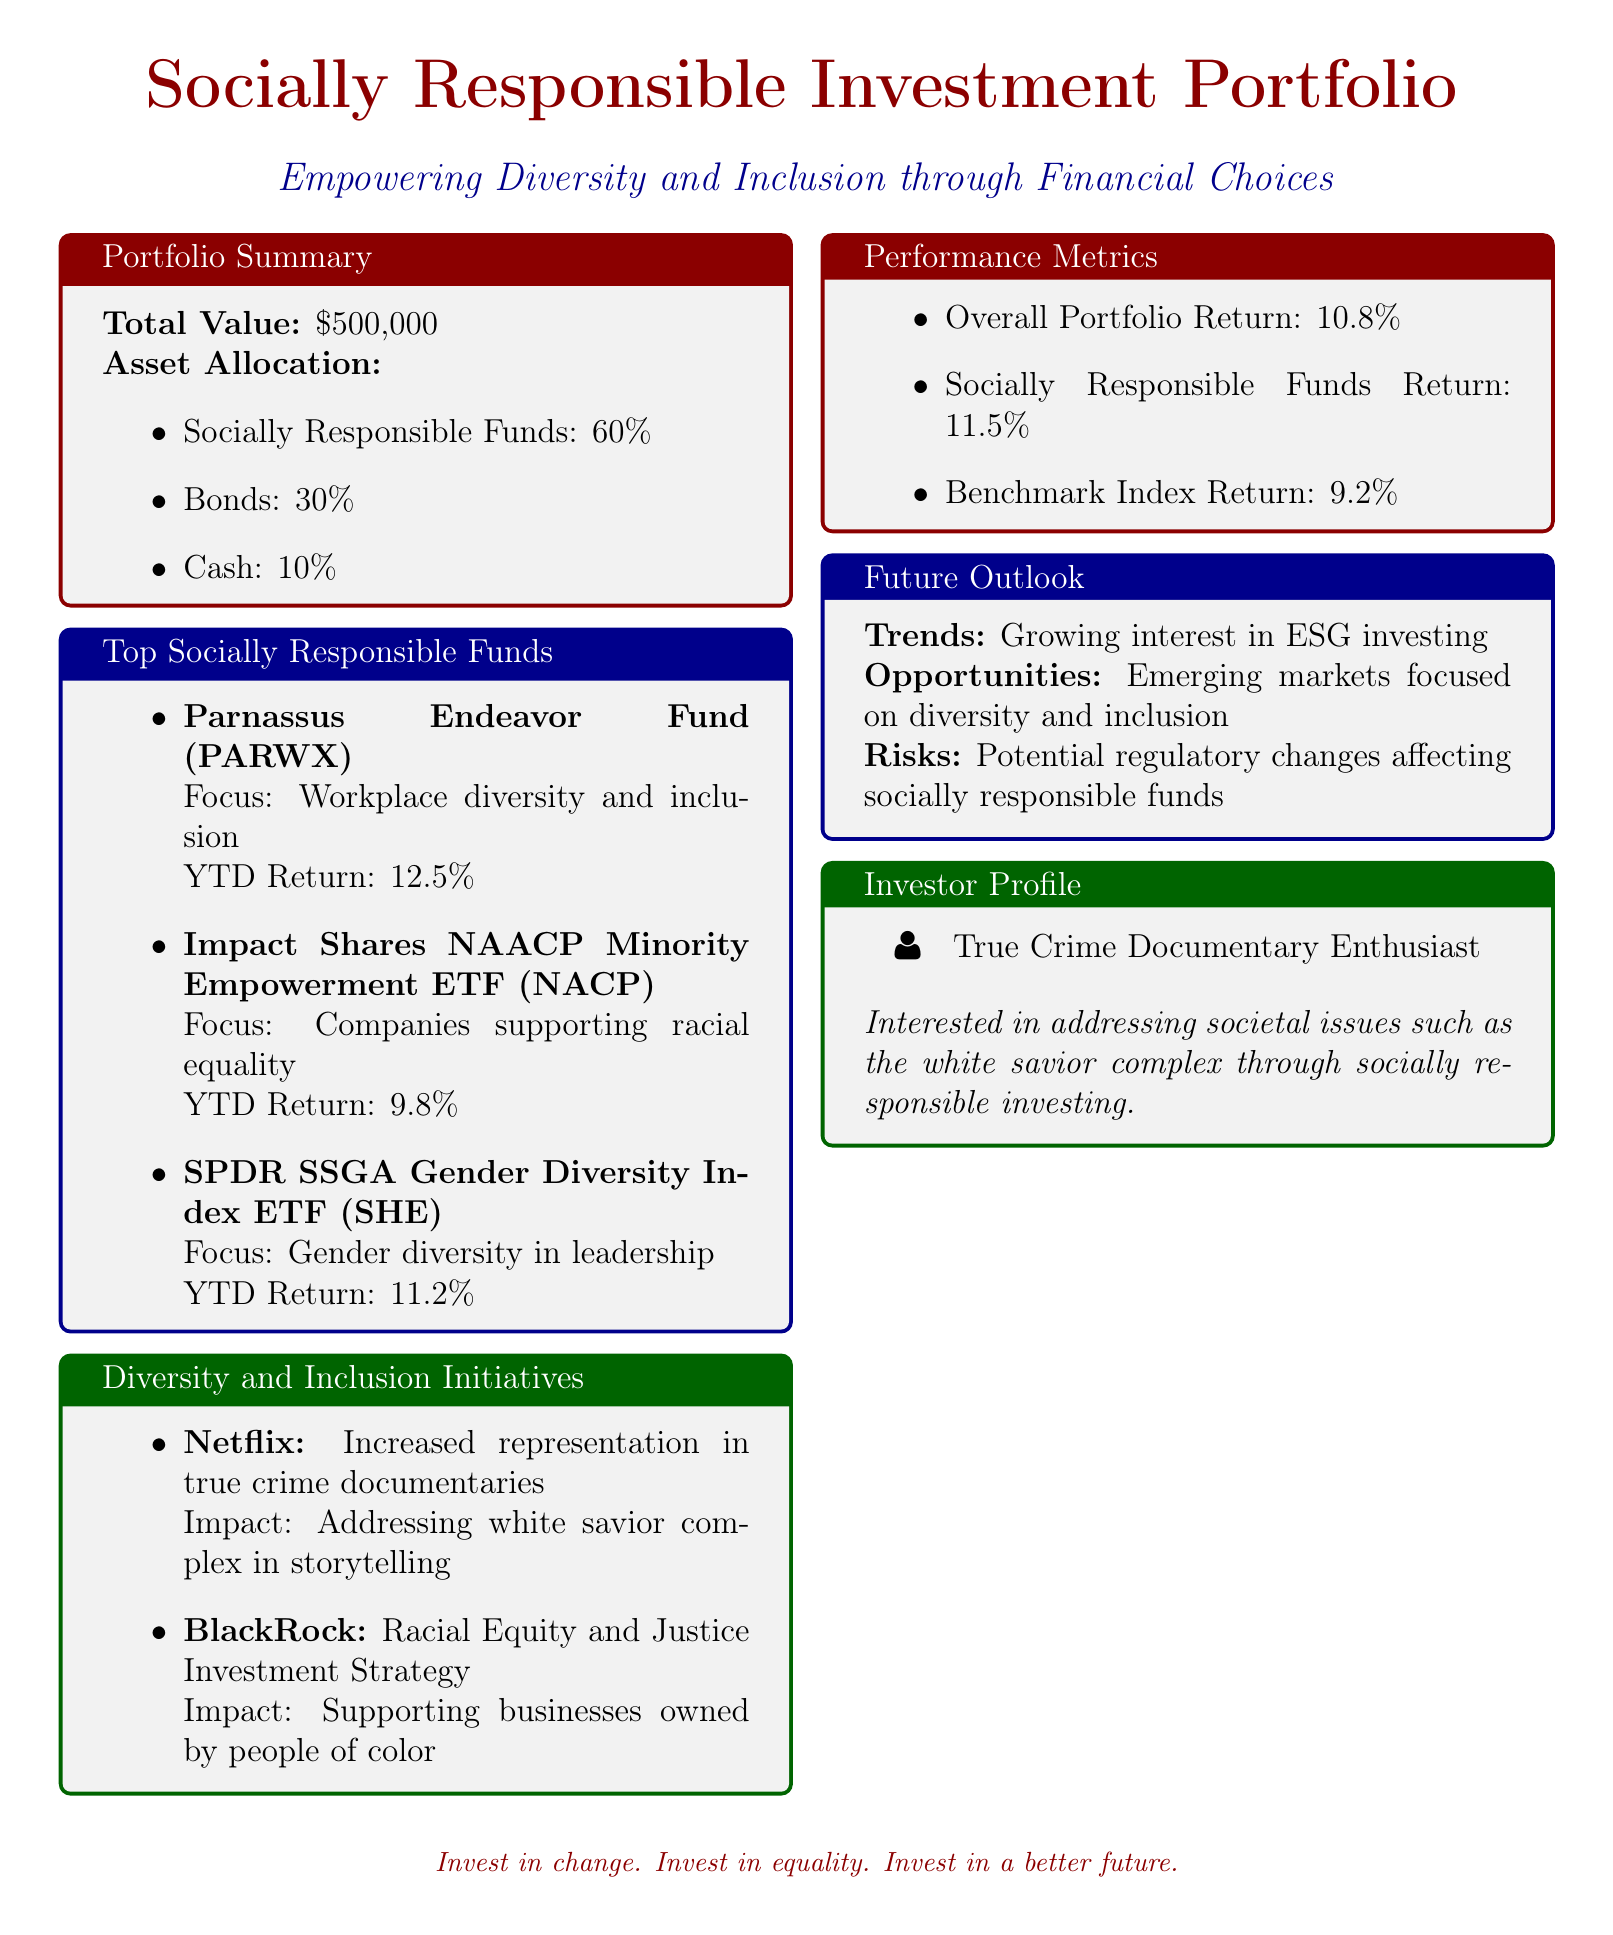What is the total value of the portfolio? The total value is explicitly stated in the portfolio summary section of the document.
Answer: $500,000 What percentage of the asset allocation is in socially responsible funds? The document specifies the percentage allocated to socially responsible funds in the asset allocation section.
Answer: 60% Which fund focuses on workplace diversity and inclusion? The top socially responsible funds section lists several funds, one of which focuses on workplace diversity and inclusion.
Answer: Parnassus Endeavor Fund What is the year-to-date return for the SPDR SSGA Gender Diversity Index ETF? The year-to-date return for this specific fund is provided in the top socially responsible funds section.
Answer: 11.2% What impact does Netflix's initiative have on societal storytelling? The document details the impact of Netflix's initiative in the diversity and inclusion initiatives section.
Answer: Addressing white savior complex in storytelling What is the overall portfolio return? The performance metrics section includes the overall portfolio return value.
Answer: 10.8% What is identified as a trend in the future outlook? The future outlook section discusses current and future trends relevant to the portfolio.
Answer: Growing interest in ESG investing Which company has an investment strategy focused on racial equity and justice? The diversity and inclusion initiatives section names companies and their respective initiatives addressing these issues.
Answer: BlackRock What percentage return did socially responsible funds achieve? This information is specified in the performance metrics section of the document.
Answer: 11.5% 